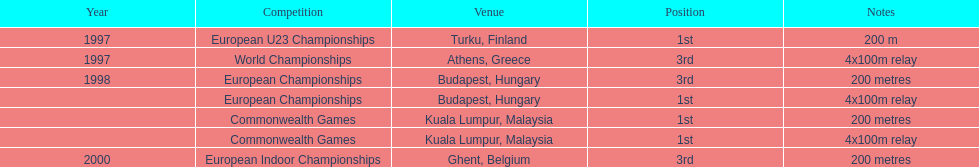In what year did england get the top achievment in the 200 meter? 1997. 